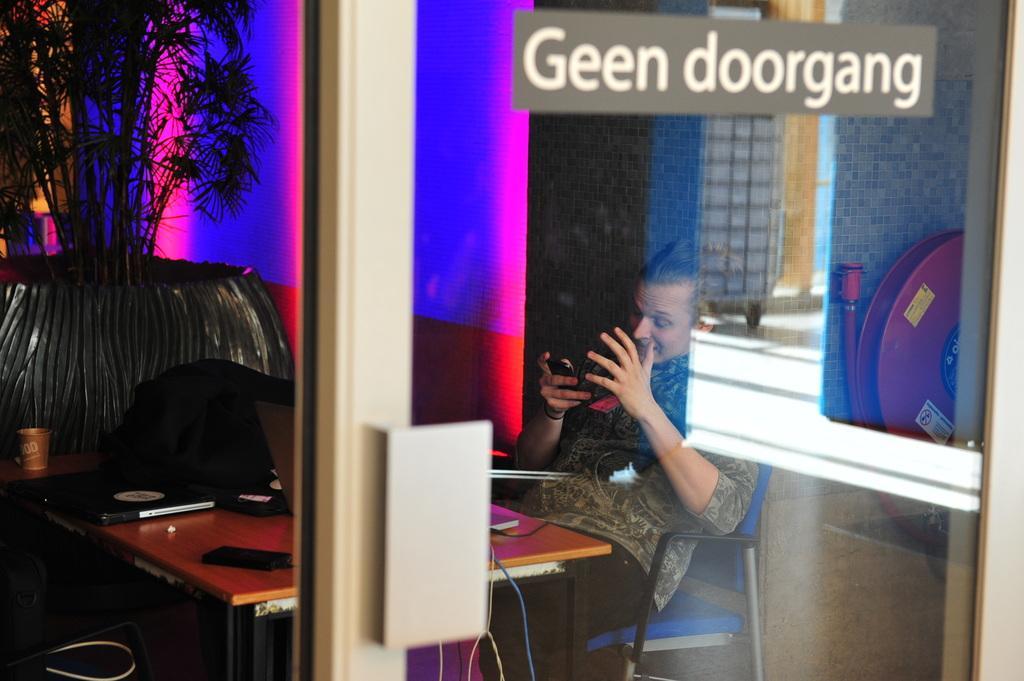Could you give a brief overview of what you see in this image? In the front there is a door. A person is sitting on chair watching mobile. In front of him there is a table. On the table there is a laptop and some other items are there. In the back there is a pot, in this there is a plant. In the background there are different colors. 